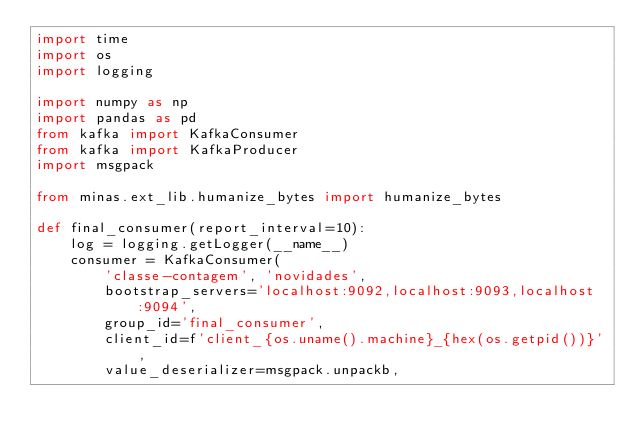<code> <loc_0><loc_0><loc_500><loc_500><_Python_>import time
import os
import logging

import numpy as np
import pandas as pd
from kafka import KafkaConsumer
from kafka import KafkaProducer
import msgpack

from minas.ext_lib.humanize_bytes import humanize_bytes

def final_consumer(report_interval=10):
    log = logging.getLogger(__name__)
    consumer = KafkaConsumer(
        'classe-contagem', 'novidades',
        bootstrap_servers='localhost:9092,localhost:9093,localhost:9094',
        group_id='final_consumer',
        client_id=f'client_{os.uname().machine}_{hex(os.getpid())}',
        value_deserializer=msgpack.unpackb,</code> 